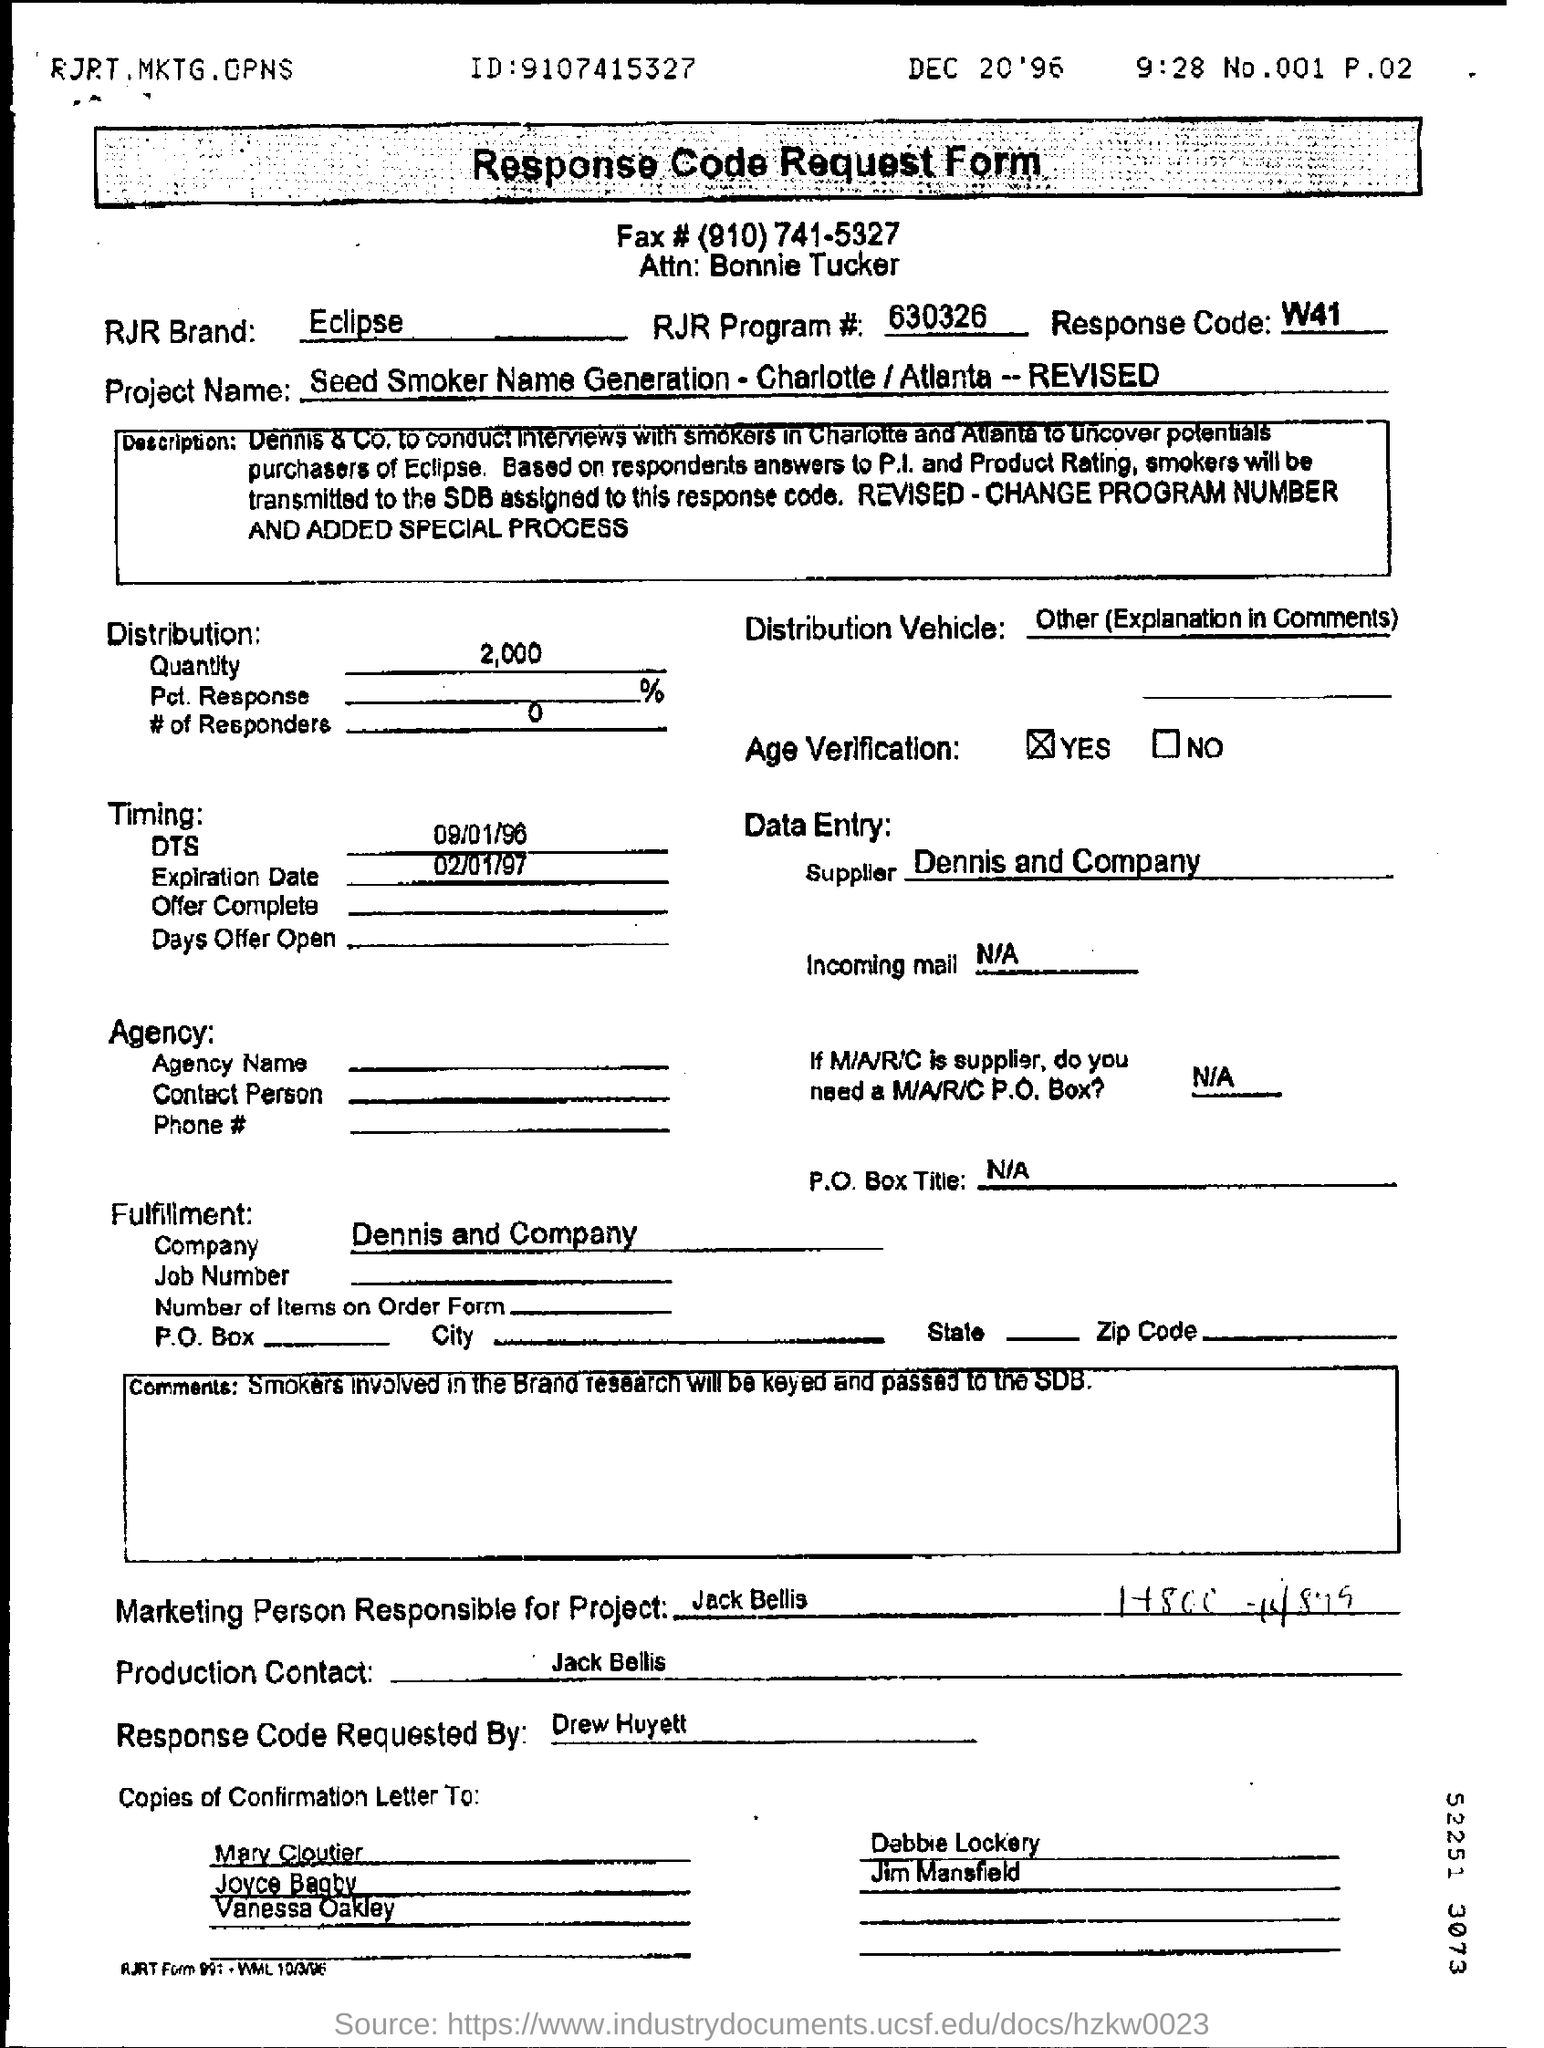Give some essential details in this illustration. This offer will expire on February 1st, 1997. The individual responsible for the project's marketing efforts is Jack Bellis. Dennis and Company is the supplier. The response code mentioned on the form is W41. The individual who requested the response code for the request form is Drew Huyett. 